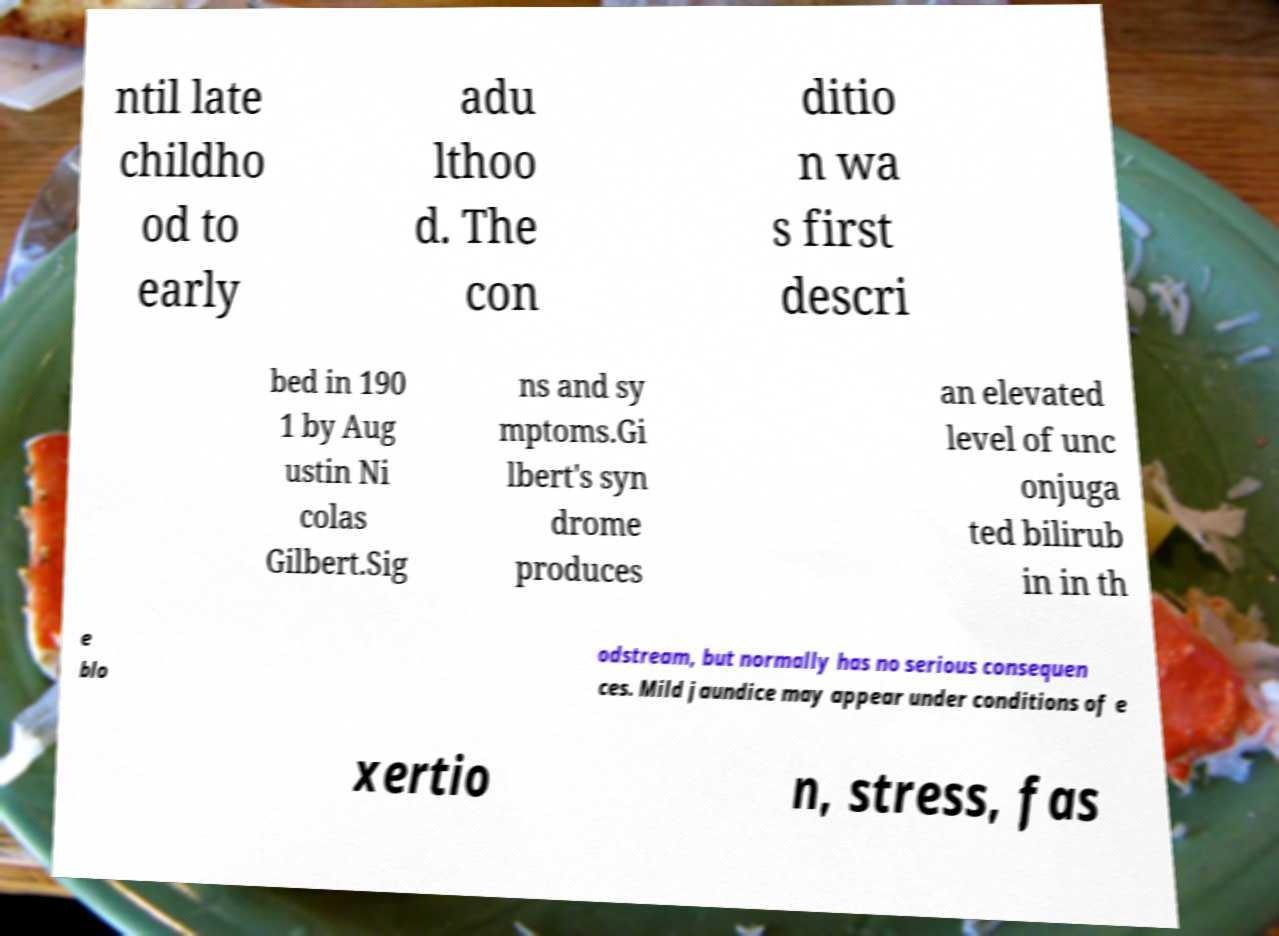Can you accurately transcribe the text from the provided image for me? ntil late childho od to early adu lthoo d. The con ditio n wa s first descri bed in 190 1 by Aug ustin Ni colas Gilbert.Sig ns and sy mptoms.Gi lbert's syn drome produces an elevated level of unc onjuga ted bilirub in in th e blo odstream, but normally has no serious consequen ces. Mild jaundice may appear under conditions of e xertio n, stress, fas 